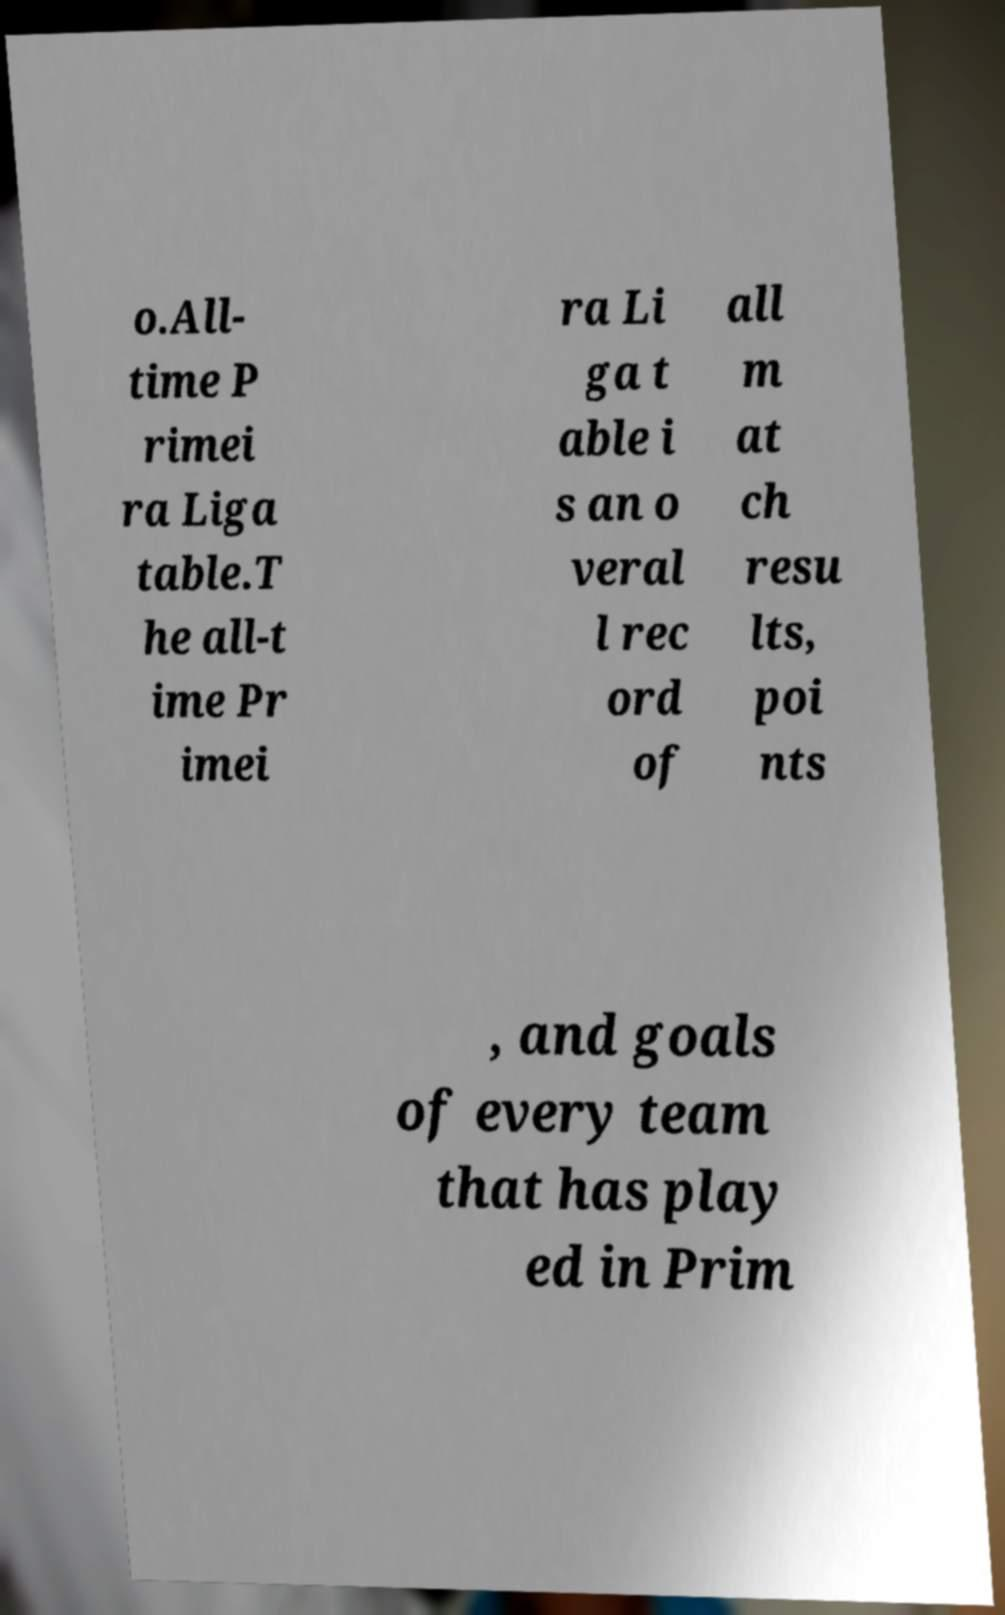What messages or text are displayed in this image? I need them in a readable, typed format. o.All- time P rimei ra Liga table.T he all-t ime Pr imei ra Li ga t able i s an o veral l rec ord of all m at ch resu lts, poi nts , and goals of every team that has play ed in Prim 